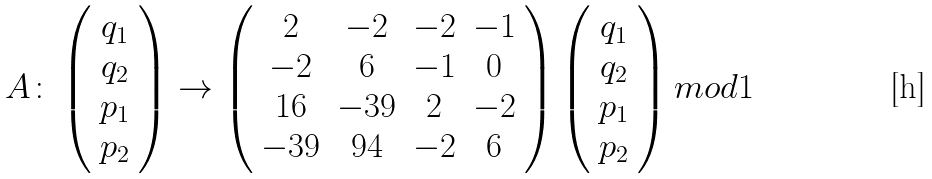Convert formula to latex. <formula><loc_0><loc_0><loc_500><loc_500>A \colon \left ( \begin{array} { c } q _ { 1 } \\ q _ { 2 } \\ p _ { 1 } \\ p _ { 2 } \end{array} \right ) \rightarrow \left ( \begin{array} { c c c c } 2 & - 2 & - 2 & - 1 \\ - 2 & 6 & - 1 & 0 \\ 1 6 & - 3 9 & 2 & - 2 \\ - 3 9 & 9 4 & - 2 & 6 \end{array} \right ) \left ( \begin{array} { c } q _ { 1 } \\ q _ { 2 } \\ p _ { 1 } \\ p _ { 2 } \end{array} \right ) m o d 1</formula> 